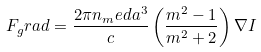Convert formula to latex. <formula><loc_0><loc_0><loc_500><loc_500>F _ { g } r a d = \frac { 2 \pi n _ { m } e d a ^ { 3 } } { c } \left ( \frac { m ^ { 2 } - 1 } { m ^ { 2 } + 2 } \right ) \nabla I</formula> 